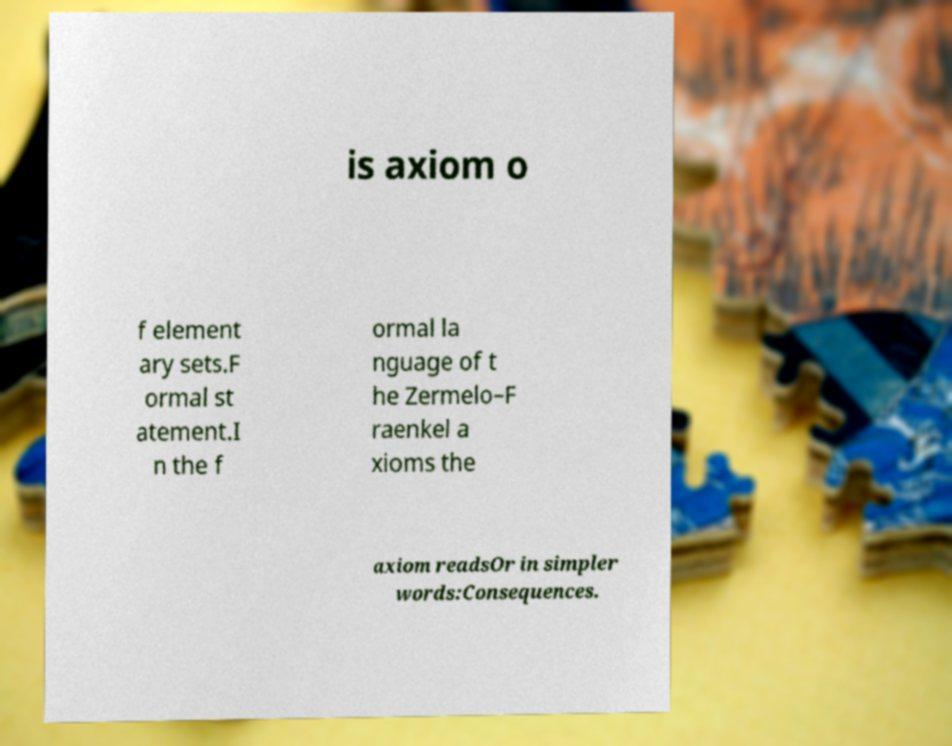I need the written content from this picture converted into text. Can you do that? is axiom o f element ary sets.F ormal st atement.I n the f ormal la nguage of t he Zermelo–F raenkel a xioms the axiom readsOr in simpler words:Consequences. 